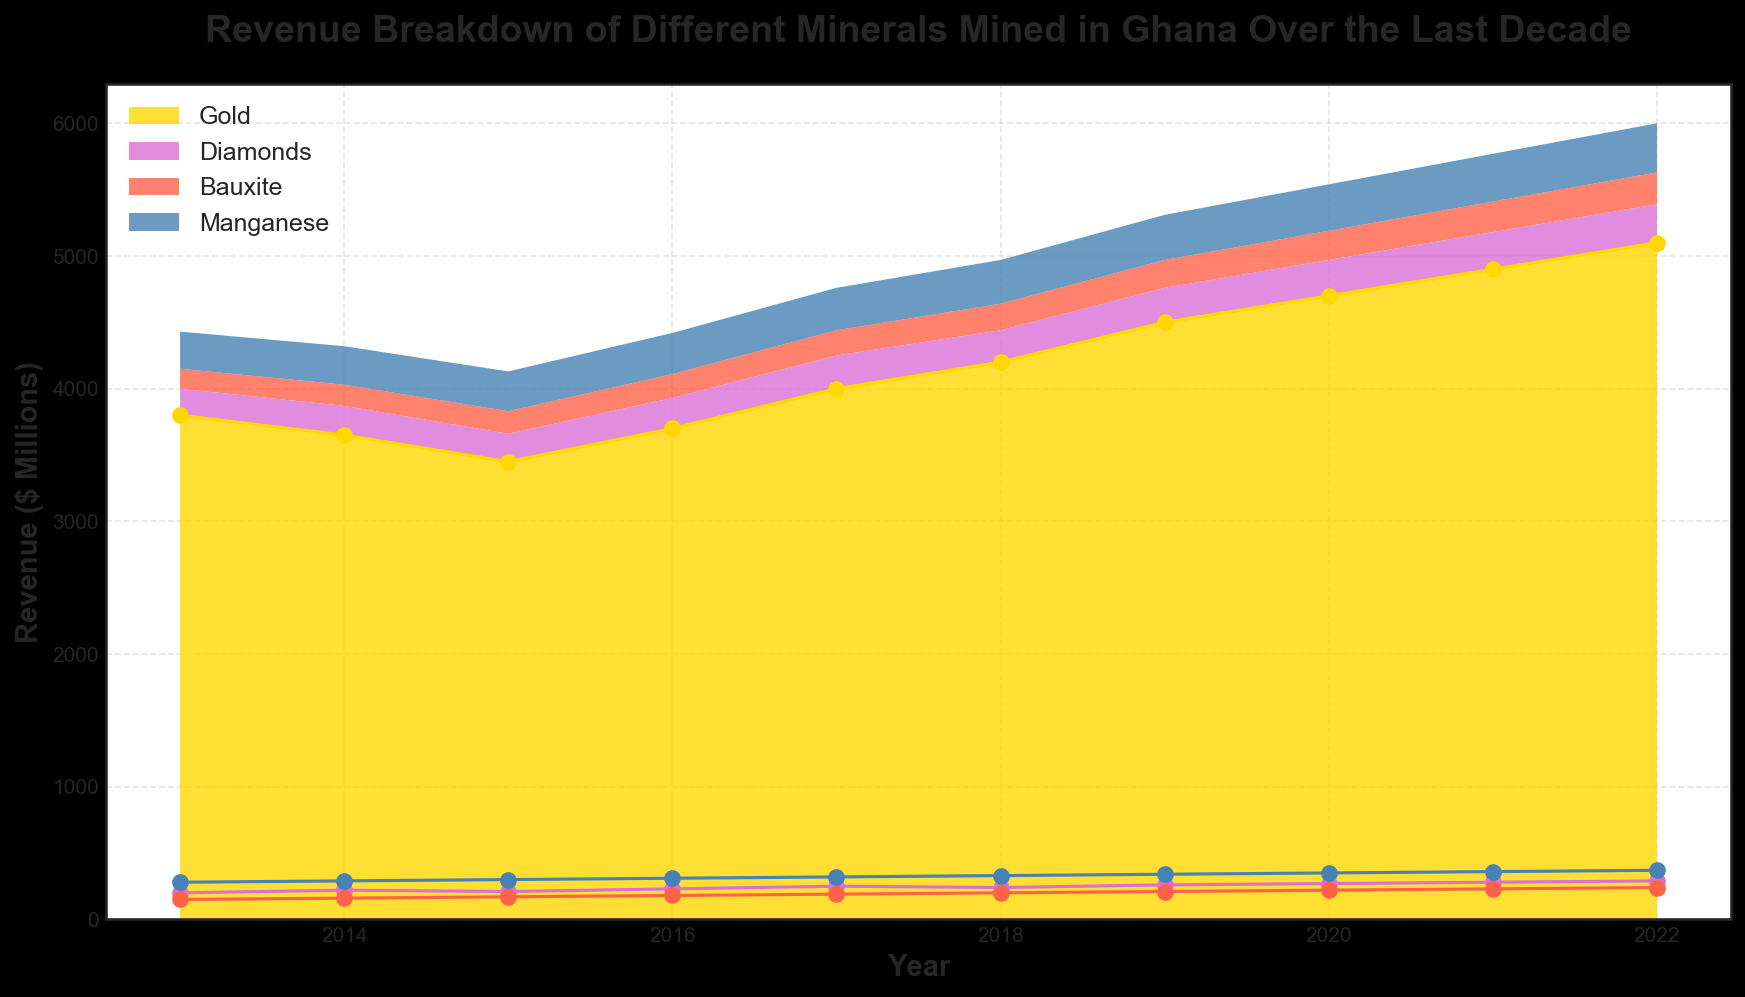What was the total revenue from mining for the year 2022? To find the total revenue, sum up the revenues from Gold, Diamonds, Bauxite, and Manganese for the year 2022. The values are Gold (5100), Diamonds (290), Bauxite (240), and Manganese (370). Thus, 5100 + 290 + 240 + 370 = 6000.
Answer: 6000 Which mineral had the highest revenue in 2018? By reviewing the chart and identifying the highest area/line for the year 2018, we see that Gold has the highest individual revenue.
Answer: Gold Between which years did Gold show the largest increase in revenue? By comparing the increases between consecutive years, the largest increase occurs between 2018 (4200) and 2019 (4500), which is an increase of 300.
Answer: 2018-2019 How did the revenue of Diamonds change from 2014 to 2015? The revenue of Diamonds decreased from 220 in 2014 to 210 in 2015. The change is calculated as 210 - 220 = -10.
Answer: Decreased by 10 What is the average annual revenue of Bauxite over the last decade? Sum up Bauxite revenues from 2013 to 2022 (150 + 160 + 170 + 180 + 190 + 200 + 210 + 220 + 230 + 240 = 1950) and divide by 10 (years). So, 1950/10 = 195.
Answer: 195 Which mineral consistently had the lowest revenue over the years? By observing the stacked areas, Diamonds consistently had the smallest area/height compared to the other minerals over the entire period.
Answer: Diamonds Which mineral showed a steady increase in revenue every year? Upon reviewing the trajectories, Manganese shows a steady increase each year, going up by approximately 10 each year.
Answer: Manganese How does the revenue of Manganese in 2022 compare to its revenue in 2013? Manganese's revenue in 2022 is 370, and in 2013 it was 280. The difference (370 - 280) is an increase of 90.
Answer: Increased by 90 What was the combined revenue of Gold and Bauxite in 2019? The revenue for Gold in 2019 was 4500 and for Bauxite it was 210. The combined revenue is 4500 + 210 = 4710.
Answer: 4710 What is the visual trend of Gold's revenue over a decade? The visual trend of Gold's revenue first saw a decline until 2015, followed by a continuous increase from 2016 onwards.
Answer: Decrease then Increase 